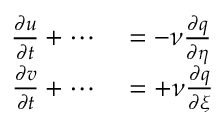Convert formula to latex. <formula><loc_0><loc_0><loc_500><loc_500>\begin{array} { r l } { \frac { \partial u } { \partial t } + \cdots } & = - \nu \frac { \partial q } { \partial \eta } } \\ { \frac { \partial v } { \partial t } + \cdots } & = + \nu \frac { \partial q } { \partial \xi } } \end{array}</formula> 